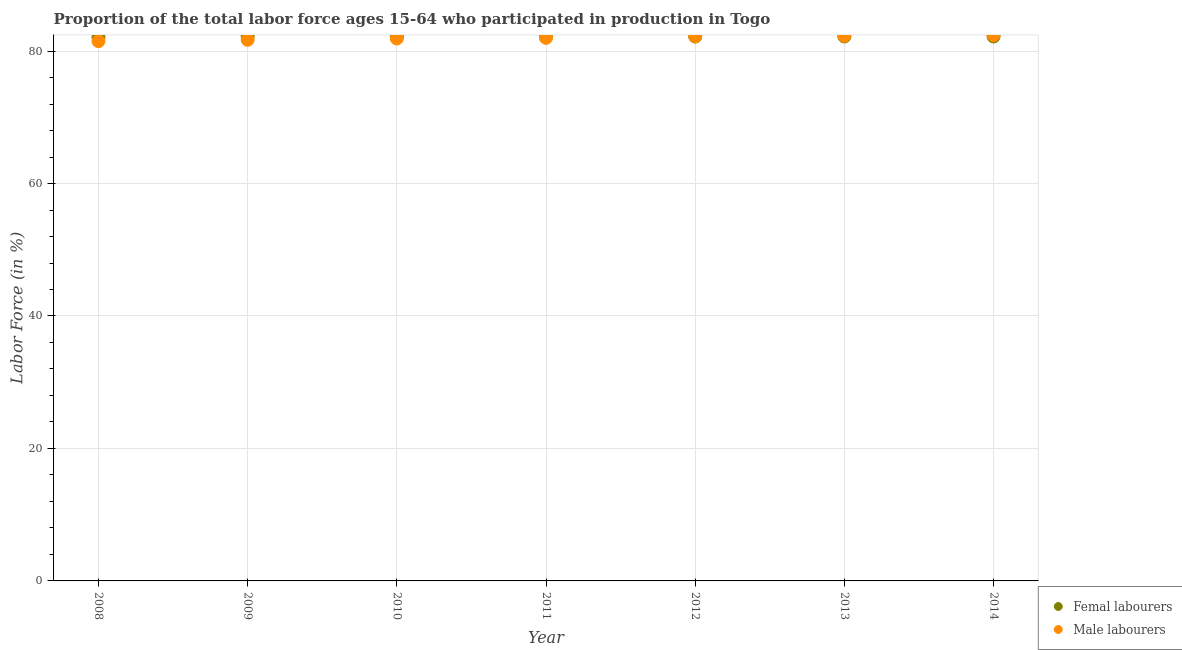What is the percentage of female labor force in 2013?
Your response must be concise. 82.2. Across all years, what is the maximum percentage of male labour force?
Provide a short and direct response. 82.4. Across all years, what is the minimum percentage of male labour force?
Your answer should be compact. 81.5. What is the total percentage of female labor force in the graph?
Give a very brief answer. 575.3. What is the difference between the percentage of male labour force in 2011 and that in 2014?
Give a very brief answer. -0.4. What is the difference between the percentage of female labor force in 2012 and the percentage of male labour force in 2009?
Offer a very short reply. 0.5. What is the average percentage of female labor force per year?
Ensure brevity in your answer.  82.19. In the year 2011, what is the difference between the percentage of female labor force and percentage of male labour force?
Make the answer very short. 0.2. In how many years, is the percentage of male labour force greater than 4 %?
Your answer should be very brief. 7. What is the ratio of the percentage of female labor force in 2009 to that in 2011?
Your response must be concise. 1. Is the percentage of male labour force in 2012 less than that in 2014?
Provide a short and direct response. Yes. What is the difference between the highest and the second highest percentage of male labour force?
Provide a succinct answer. 0.1. What is the difference between the highest and the lowest percentage of female labor force?
Offer a terse response. 0.1. In how many years, is the percentage of male labour force greater than the average percentage of male labour force taken over all years?
Keep it short and to the point. 3. Does the percentage of female labor force monotonically increase over the years?
Offer a very short reply. No. How many years are there in the graph?
Offer a very short reply. 7. What is the difference between two consecutive major ticks on the Y-axis?
Keep it short and to the point. 20. Are the values on the major ticks of Y-axis written in scientific E-notation?
Provide a short and direct response. No. Does the graph contain grids?
Your answer should be compact. Yes. Where does the legend appear in the graph?
Keep it short and to the point. Bottom right. How many legend labels are there?
Offer a very short reply. 2. What is the title of the graph?
Make the answer very short. Proportion of the total labor force ages 15-64 who participated in production in Togo. Does "Travel Items" appear as one of the legend labels in the graph?
Keep it short and to the point. No. What is the label or title of the X-axis?
Ensure brevity in your answer.  Year. What is the label or title of the Y-axis?
Your response must be concise. Labor Force (in %). What is the Labor Force (in %) of Femal labourers in 2008?
Give a very brief answer. 82.1. What is the Labor Force (in %) of Male labourers in 2008?
Make the answer very short. 81.5. What is the Labor Force (in %) in Femal labourers in 2009?
Your answer should be very brief. 82.2. What is the Labor Force (in %) in Male labourers in 2009?
Offer a terse response. 81.7. What is the Labor Force (in %) of Femal labourers in 2010?
Your response must be concise. 82.2. What is the Labor Force (in %) of Male labourers in 2010?
Provide a short and direct response. 81.9. What is the Labor Force (in %) in Femal labourers in 2011?
Give a very brief answer. 82.2. What is the Labor Force (in %) of Femal labourers in 2012?
Offer a very short reply. 82.2. What is the Labor Force (in %) in Male labourers in 2012?
Make the answer very short. 82.2. What is the Labor Force (in %) of Femal labourers in 2013?
Offer a very short reply. 82.2. What is the Labor Force (in %) in Male labourers in 2013?
Your answer should be very brief. 82.3. What is the Labor Force (in %) in Femal labourers in 2014?
Offer a terse response. 82.2. What is the Labor Force (in %) in Male labourers in 2014?
Keep it short and to the point. 82.4. Across all years, what is the maximum Labor Force (in %) in Femal labourers?
Provide a short and direct response. 82.2. Across all years, what is the maximum Labor Force (in %) in Male labourers?
Offer a very short reply. 82.4. Across all years, what is the minimum Labor Force (in %) in Femal labourers?
Keep it short and to the point. 82.1. Across all years, what is the minimum Labor Force (in %) in Male labourers?
Your answer should be very brief. 81.5. What is the total Labor Force (in %) in Femal labourers in the graph?
Make the answer very short. 575.3. What is the total Labor Force (in %) of Male labourers in the graph?
Keep it short and to the point. 574. What is the difference between the Labor Force (in %) in Femal labourers in 2008 and that in 2010?
Provide a short and direct response. -0.1. What is the difference between the Labor Force (in %) in Male labourers in 2008 and that in 2010?
Offer a terse response. -0.4. What is the difference between the Labor Force (in %) of Femal labourers in 2008 and that in 2011?
Offer a terse response. -0.1. What is the difference between the Labor Force (in %) in Male labourers in 2008 and that in 2011?
Your answer should be compact. -0.5. What is the difference between the Labor Force (in %) of Femal labourers in 2008 and that in 2012?
Give a very brief answer. -0.1. What is the difference between the Labor Force (in %) of Male labourers in 2008 and that in 2012?
Keep it short and to the point. -0.7. What is the difference between the Labor Force (in %) in Femal labourers in 2008 and that in 2013?
Provide a short and direct response. -0.1. What is the difference between the Labor Force (in %) of Male labourers in 2008 and that in 2013?
Provide a succinct answer. -0.8. What is the difference between the Labor Force (in %) in Femal labourers in 2008 and that in 2014?
Your answer should be very brief. -0.1. What is the difference between the Labor Force (in %) in Male labourers in 2008 and that in 2014?
Keep it short and to the point. -0.9. What is the difference between the Labor Force (in %) in Femal labourers in 2009 and that in 2010?
Give a very brief answer. 0. What is the difference between the Labor Force (in %) of Male labourers in 2009 and that in 2010?
Offer a terse response. -0.2. What is the difference between the Labor Force (in %) in Femal labourers in 2009 and that in 2011?
Give a very brief answer. 0. What is the difference between the Labor Force (in %) of Femal labourers in 2009 and that in 2013?
Give a very brief answer. 0. What is the difference between the Labor Force (in %) in Male labourers in 2009 and that in 2013?
Give a very brief answer. -0.6. What is the difference between the Labor Force (in %) in Femal labourers in 2010 and that in 2011?
Offer a terse response. 0. What is the difference between the Labor Force (in %) in Femal labourers in 2010 and that in 2012?
Keep it short and to the point. 0. What is the difference between the Labor Force (in %) of Femal labourers in 2010 and that in 2013?
Your answer should be compact. 0. What is the difference between the Labor Force (in %) in Femal labourers in 2010 and that in 2014?
Your response must be concise. 0. What is the difference between the Labor Force (in %) in Femal labourers in 2011 and that in 2012?
Offer a terse response. 0. What is the difference between the Labor Force (in %) in Male labourers in 2011 and that in 2012?
Ensure brevity in your answer.  -0.2. What is the difference between the Labor Force (in %) in Femal labourers in 2011 and that in 2013?
Offer a terse response. 0. What is the difference between the Labor Force (in %) in Femal labourers in 2011 and that in 2014?
Your answer should be compact. 0. What is the difference between the Labor Force (in %) of Male labourers in 2011 and that in 2014?
Offer a very short reply. -0.4. What is the difference between the Labor Force (in %) of Male labourers in 2012 and that in 2013?
Provide a succinct answer. -0.1. What is the difference between the Labor Force (in %) in Femal labourers in 2012 and that in 2014?
Your answer should be compact. 0. What is the difference between the Labor Force (in %) of Male labourers in 2012 and that in 2014?
Keep it short and to the point. -0.2. What is the difference between the Labor Force (in %) in Femal labourers in 2013 and that in 2014?
Offer a very short reply. 0. What is the difference between the Labor Force (in %) of Femal labourers in 2008 and the Labor Force (in %) of Male labourers in 2009?
Keep it short and to the point. 0.4. What is the difference between the Labor Force (in %) in Femal labourers in 2008 and the Labor Force (in %) in Male labourers in 2011?
Your answer should be very brief. 0.1. What is the difference between the Labor Force (in %) of Femal labourers in 2008 and the Labor Force (in %) of Male labourers in 2013?
Offer a very short reply. -0.2. What is the difference between the Labor Force (in %) in Femal labourers in 2008 and the Labor Force (in %) in Male labourers in 2014?
Offer a terse response. -0.3. What is the difference between the Labor Force (in %) in Femal labourers in 2009 and the Labor Force (in %) in Male labourers in 2010?
Your response must be concise. 0.3. What is the difference between the Labor Force (in %) in Femal labourers in 2009 and the Labor Force (in %) in Male labourers in 2012?
Your answer should be very brief. 0. What is the difference between the Labor Force (in %) in Femal labourers in 2009 and the Labor Force (in %) in Male labourers in 2013?
Provide a short and direct response. -0.1. What is the difference between the Labor Force (in %) of Femal labourers in 2009 and the Labor Force (in %) of Male labourers in 2014?
Your answer should be very brief. -0.2. What is the difference between the Labor Force (in %) of Femal labourers in 2010 and the Labor Force (in %) of Male labourers in 2011?
Offer a very short reply. 0.2. What is the difference between the Labor Force (in %) in Femal labourers in 2010 and the Labor Force (in %) in Male labourers in 2012?
Provide a short and direct response. 0. What is the difference between the Labor Force (in %) in Femal labourers in 2010 and the Labor Force (in %) in Male labourers in 2013?
Give a very brief answer. -0.1. What is the difference between the Labor Force (in %) in Femal labourers in 2011 and the Labor Force (in %) in Male labourers in 2013?
Your answer should be compact. -0.1. What is the difference between the Labor Force (in %) in Femal labourers in 2012 and the Labor Force (in %) in Male labourers in 2014?
Your response must be concise. -0.2. What is the average Labor Force (in %) in Femal labourers per year?
Offer a very short reply. 82.19. What is the average Labor Force (in %) in Male labourers per year?
Keep it short and to the point. 82. In the year 2009, what is the difference between the Labor Force (in %) of Femal labourers and Labor Force (in %) of Male labourers?
Your response must be concise. 0.5. In the year 2010, what is the difference between the Labor Force (in %) of Femal labourers and Labor Force (in %) of Male labourers?
Offer a very short reply. 0.3. In the year 2011, what is the difference between the Labor Force (in %) of Femal labourers and Labor Force (in %) of Male labourers?
Provide a short and direct response. 0.2. In the year 2012, what is the difference between the Labor Force (in %) of Femal labourers and Labor Force (in %) of Male labourers?
Provide a succinct answer. 0. In the year 2013, what is the difference between the Labor Force (in %) of Femal labourers and Labor Force (in %) of Male labourers?
Your answer should be compact. -0.1. In the year 2014, what is the difference between the Labor Force (in %) in Femal labourers and Labor Force (in %) in Male labourers?
Give a very brief answer. -0.2. What is the ratio of the Labor Force (in %) of Femal labourers in 2008 to that in 2009?
Provide a short and direct response. 1. What is the ratio of the Labor Force (in %) of Femal labourers in 2008 to that in 2010?
Keep it short and to the point. 1. What is the ratio of the Labor Force (in %) in Male labourers in 2008 to that in 2010?
Your response must be concise. 1. What is the ratio of the Labor Force (in %) in Femal labourers in 2008 to that in 2011?
Ensure brevity in your answer.  1. What is the ratio of the Labor Force (in %) in Femal labourers in 2008 to that in 2012?
Your response must be concise. 1. What is the ratio of the Labor Force (in %) of Male labourers in 2008 to that in 2013?
Your answer should be very brief. 0.99. What is the ratio of the Labor Force (in %) of Femal labourers in 2009 to that in 2010?
Ensure brevity in your answer.  1. What is the ratio of the Labor Force (in %) of Male labourers in 2009 to that in 2010?
Your response must be concise. 1. What is the ratio of the Labor Force (in %) in Male labourers in 2009 to that in 2011?
Offer a very short reply. 1. What is the ratio of the Labor Force (in %) of Male labourers in 2009 to that in 2014?
Make the answer very short. 0.99. What is the ratio of the Labor Force (in %) of Femal labourers in 2010 to that in 2011?
Provide a succinct answer. 1. What is the ratio of the Labor Force (in %) of Male labourers in 2010 to that in 2011?
Your answer should be very brief. 1. What is the ratio of the Labor Force (in %) in Male labourers in 2010 to that in 2012?
Ensure brevity in your answer.  1. What is the ratio of the Labor Force (in %) of Femal labourers in 2010 to that in 2013?
Provide a succinct answer. 1. What is the ratio of the Labor Force (in %) of Male labourers in 2011 to that in 2012?
Offer a terse response. 1. What is the ratio of the Labor Force (in %) in Male labourers in 2011 to that in 2014?
Offer a terse response. 1. What is the ratio of the Labor Force (in %) of Femal labourers in 2012 to that in 2013?
Provide a succinct answer. 1. What is the ratio of the Labor Force (in %) of Male labourers in 2012 to that in 2013?
Offer a terse response. 1. What is the ratio of the Labor Force (in %) of Male labourers in 2012 to that in 2014?
Your answer should be compact. 1. What is the ratio of the Labor Force (in %) of Femal labourers in 2013 to that in 2014?
Keep it short and to the point. 1. What is the difference between the highest and the second highest Labor Force (in %) of Femal labourers?
Make the answer very short. 0. What is the difference between the highest and the second highest Labor Force (in %) of Male labourers?
Provide a succinct answer. 0.1. 